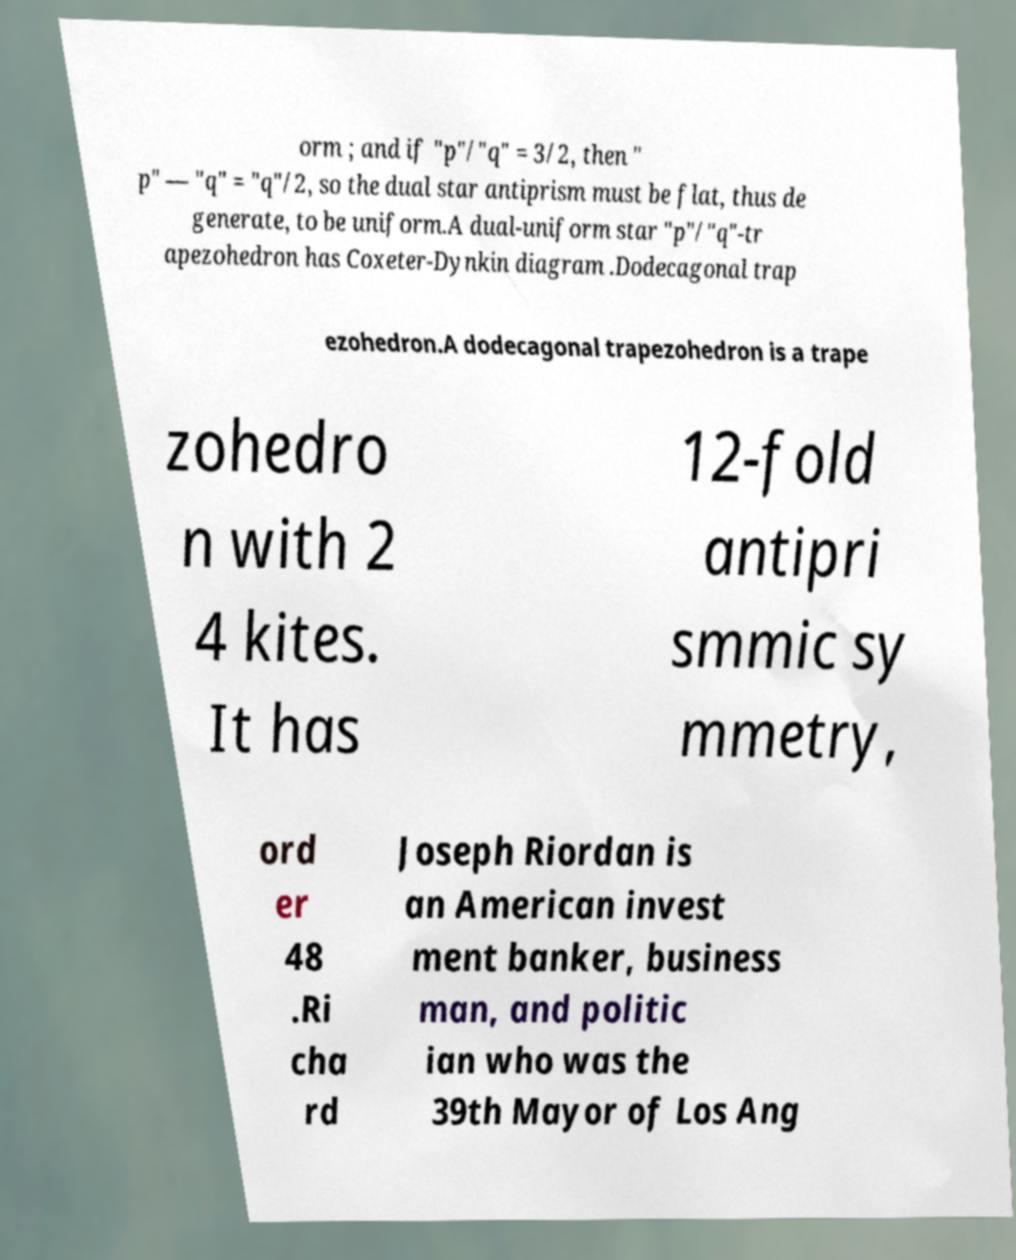Please identify and transcribe the text found in this image. orm ; and if "p"/"q" = 3/2, then " p" — "q" = "q"/2, so the dual star antiprism must be flat, thus de generate, to be uniform.A dual-uniform star "p"/"q"-tr apezohedron has Coxeter-Dynkin diagram .Dodecagonal trap ezohedron.A dodecagonal trapezohedron is a trape zohedro n with 2 4 kites. It has 12-fold antipri smmic sy mmetry, ord er 48 .Ri cha rd Joseph Riordan is an American invest ment banker, business man, and politic ian who was the 39th Mayor of Los Ang 